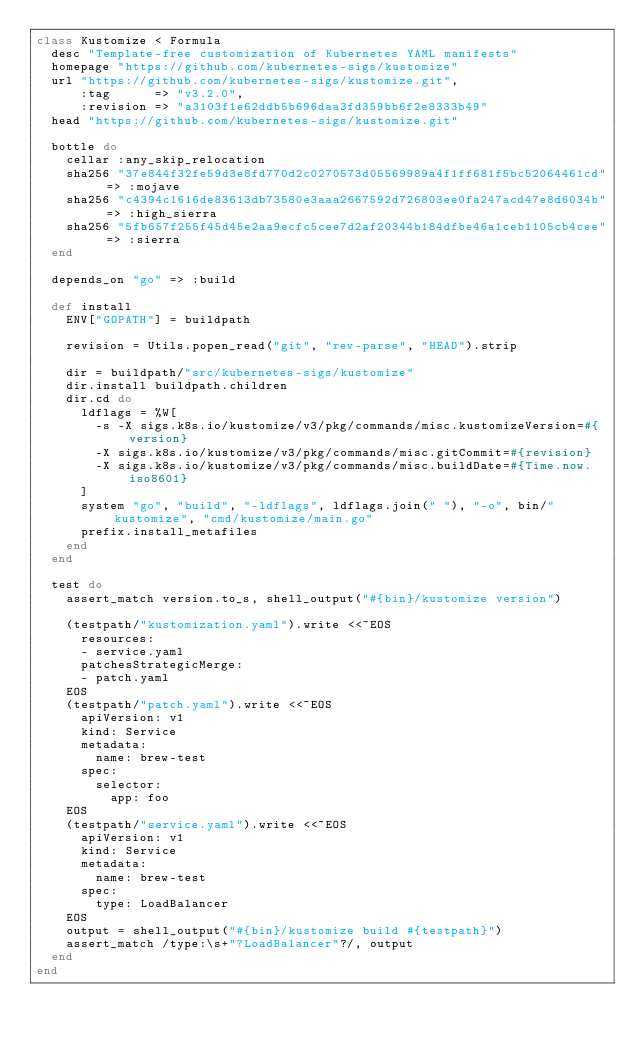Convert code to text. <code><loc_0><loc_0><loc_500><loc_500><_Ruby_>class Kustomize < Formula
  desc "Template-free customization of Kubernetes YAML manifests"
  homepage "https://github.com/kubernetes-sigs/kustomize"
  url "https://github.com/kubernetes-sigs/kustomize.git",
      :tag      => "v3.2.0",
      :revision => "a3103f1e62ddb5b696daa3fd359bb6f2e8333b49"
  head "https://github.com/kubernetes-sigs/kustomize.git"

  bottle do
    cellar :any_skip_relocation
    sha256 "37e844f32fe59d3e8fd770d2c0270573d05569989a4f1ff681f5bc52064461cd" => :mojave
    sha256 "c4394c1616de83613db73580e3aaa2667592d726803ee0fa247acd47e8d6034b" => :high_sierra
    sha256 "5fb657f255f45d45e2aa9ecfc5cee7d2af20344b184dfbe46a1ceb1105cb4cee" => :sierra
  end

  depends_on "go" => :build

  def install
    ENV["GOPATH"] = buildpath

    revision = Utils.popen_read("git", "rev-parse", "HEAD").strip

    dir = buildpath/"src/kubernetes-sigs/kustomize"
    dir.install buildpath.children
    dir.cd do
      ldflags = %W[
        -s -X sigs.k8s.io/kustomize/v3/pkg/commands/misc.kustomizeVersion=#{version}
        -X sigs.k8s.io/kustomize/v3/pkg/commands/misc.gitCommit=#{revision}
        -X sigs.k8s.io/kustomize/v3/pkg/commands/misc.buildDate=#{Time.now.iso8601}
      ]
      system "go", "build", "-ldflags", ldflags.join(" "), "-o", bin/"kustomize", "cmd/kustomize/main.go"
      prefix.install_metafiles
    end
  end

  test do
    assert_match version.to_s, shell_output("#{bin}/kustomize version")

    (testpath/"kustomization.yaml").write <<~EOS
      resources:
      - service.yaml
      patchesStrategicMerge:
      - patch.yaml
    EOS
    (testpath/"patch.yaml").write <<~EOS
      apiVersion: v1
      kind: Service
      metadata:
        name: brew-test
      spec:
        selector:
          app: foo
    EOS
    (testpath/"service.yaml").write <<~EOS
      apiVersion: v1
      kind: Service
      metadata:
        name: brew-test
      spec:
        type: LoadBalancer
    EOS
    output = shell_output("#{bin}/kustomize build #{testpath}")
    assert_match /type:\s+"?LoadBalancer"?/, output
  end
end
</code> 